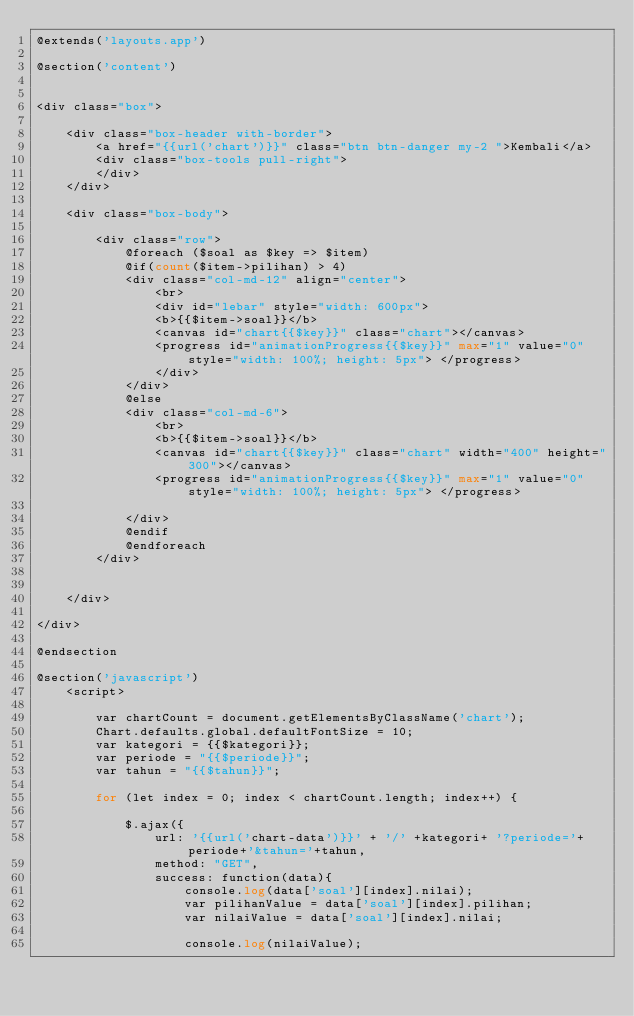Convert code to text. <code><loc_0><loc_0><loc_500><loc_500><_PHP_>@extends('layouts.app')

@section('content')


<div class="box">

    <div class="box-header with-border">
        <a href="{{url('chart')}}" class="btn btn-danger my-2 ">Kembali</a>
        <div class="box-tools pull-right">
        </div>
    </div>

    <div class="box-body">

		<div class="row">
            @foreach ($soal as $key => $item)
            @if(count($item->pilihan) > 4)
            <div class="col-md-12" align="center">
                <br>
                <div id="lebar" style="width: 600px">
		        <b>{{$item->soal}}</b>
		        <canvas id="chart{{$key}}" class="chart"></canvas>
		        <progress id="animationProgress{{$key}}" max="1" value="0" style="width: 100%; height: 5px"> </progress>
                </div>
            </div>
            @else
		    <div class="col-md-6">
				<br>
		        <b>{{$item->soal}}</b>
		        <canvas id="chart{{$key}}" class="chart" width="400" height="300"></canvas>
		        <progress id="animationProgress{{$key}}" max="1" value="0" style="width: 100%; height: 5px"> </progress>

            </div>
            @endif
		    @endforeach
		</div>
		
		
    </div>

</div>

@endsection

@section('javascript')
	<script> 
	
		var chartCount = document.getElementsByClassName('chart');
		Chart.defaults.global.defaultFontSize = 10;
        var kategori = {{$kategori}};
        var periode = "{{$periode}}";
        var tahun = "{{$tahun}}";

		for (let index = 0; index < chartCount.length; index++) {
			
			$.ajax({
				url: '{{url('chart-data')}}' + '/' +kategori+ '?periode='+periode+'&tahun='+tahun,
				method: "GET",
				success: function(data){
					console.log(data['soal'][index].nilai);
					var pilihanValue = data['soal'][index].pilihan;
					var nilaiValue = data['soal'][index].nilai;

					console.log(nilaiValue);</code> 